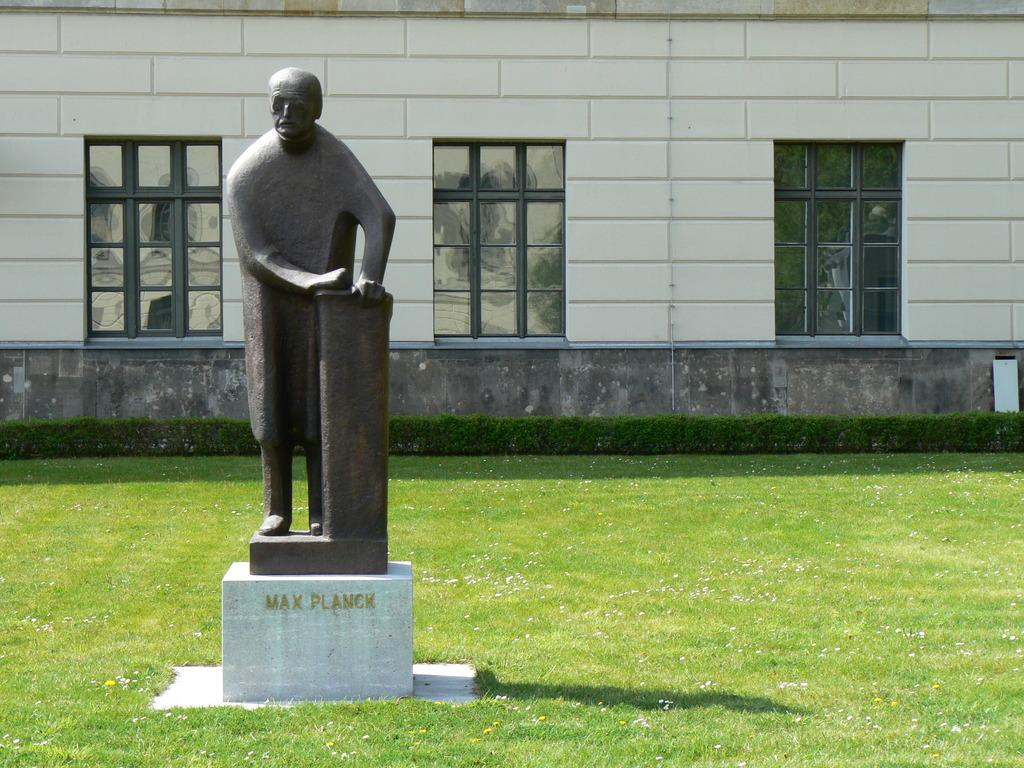What is the main subject in the picture? There is a statue in the picture. What type of material is used for the windows in the picture? There are glass windows in the picture. What is the color and texture of the grass visible in the picture? Green grass is visible in the picture. What type of underwear is the statue wearing in the picture? The statue is not wearing any underwear, as it is a non-living object and does not wear clothing. 